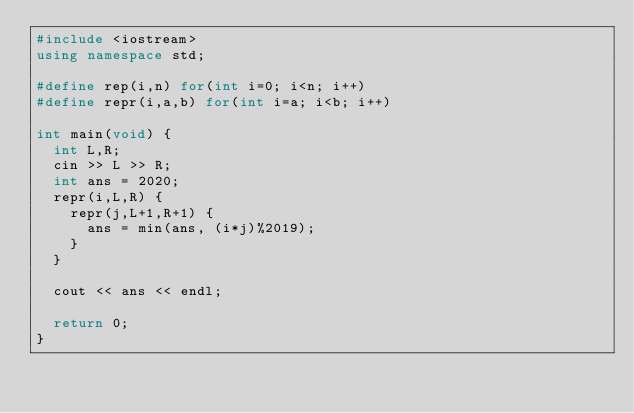<code> <loc_0><loc_0><loc_500><loc_500><_C++_>#include <iostream>
using namespace std;

#define rep(i,n) for(int i=0; i<n; i++)
#define repr(i,a,b) for(int i=a; i<b; i++)

int main(void) {
  int L,R;
  cin >> L >> R;
  int ans = 2020;
  repr(i,L,R) {
    repr(j,L+1,R+1) {
      ans = min(ans, (i*j)%2019);
    }
  }

  cout << ans << endl;

  return 0;
}</code> 